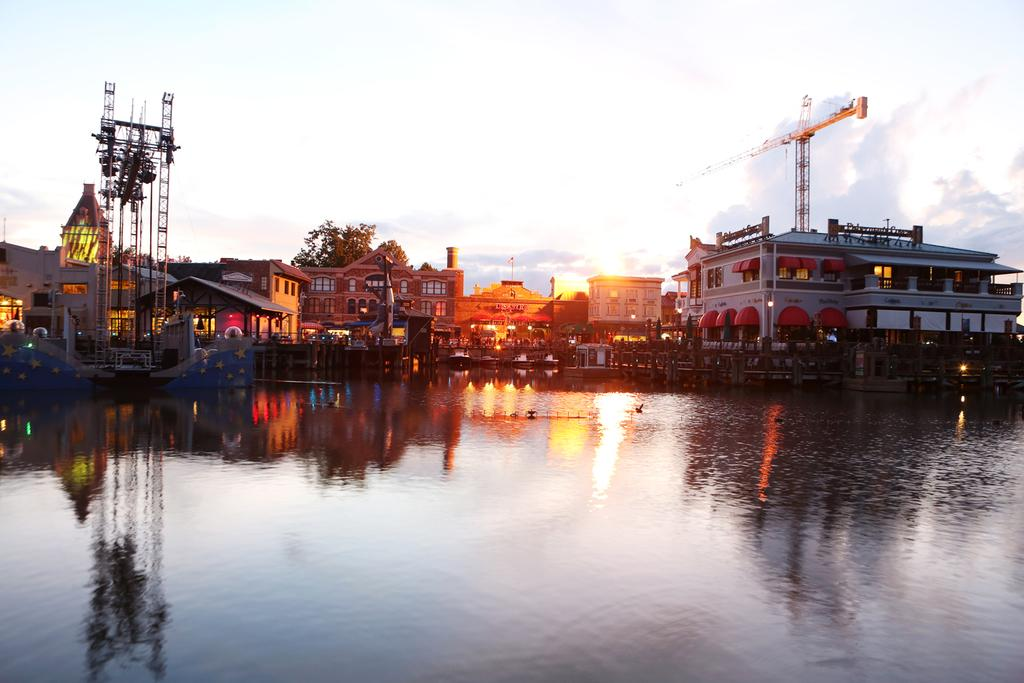What is visible in the image? Water is visible in the image. What can be seen in the background of the image? There are vehicles and trees with green color in the background of the image. How is the sky depicted in the image? The sky appears to be white in color. What type of lock can be seen securing the tank in the image? There is no tank or lock present in the image. What day of the week is depicted in the image? The image does not depict a specific day of the week. 